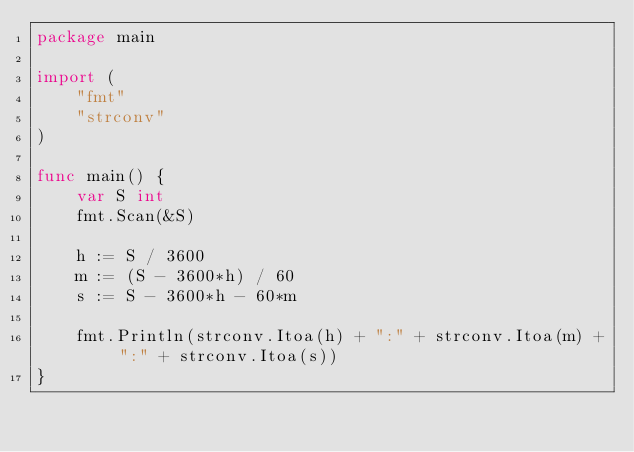Convert code to text. <code><loc_0><loc_0><loc_500><loc_500><_Go_>package main

import (
	"fmt"
	"strconv"
)

func main() {
	var S int
	fmt.Scan(&S)

	h := S / 3600
	m := (S - 3600*h) / 60
	s := S - 3600*h - 60*m

	fmt.Println(strconv.Itoa(h) + ":" + strconv.Itoa(m) + ":" + strconv.Itoa(s))
}

</code> 